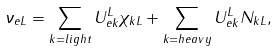Convert formula to latex. <formula><loc_0><loc_0><loc_500><loc_500>\nu _ { e L } = \sum _ { k = l i g h t } U ^ { L } _ { e k } \chi _ { k L } + \sum _ { k = h e a v y } U ^ { L } _ { e k } N _ { k L } ,</formula> 